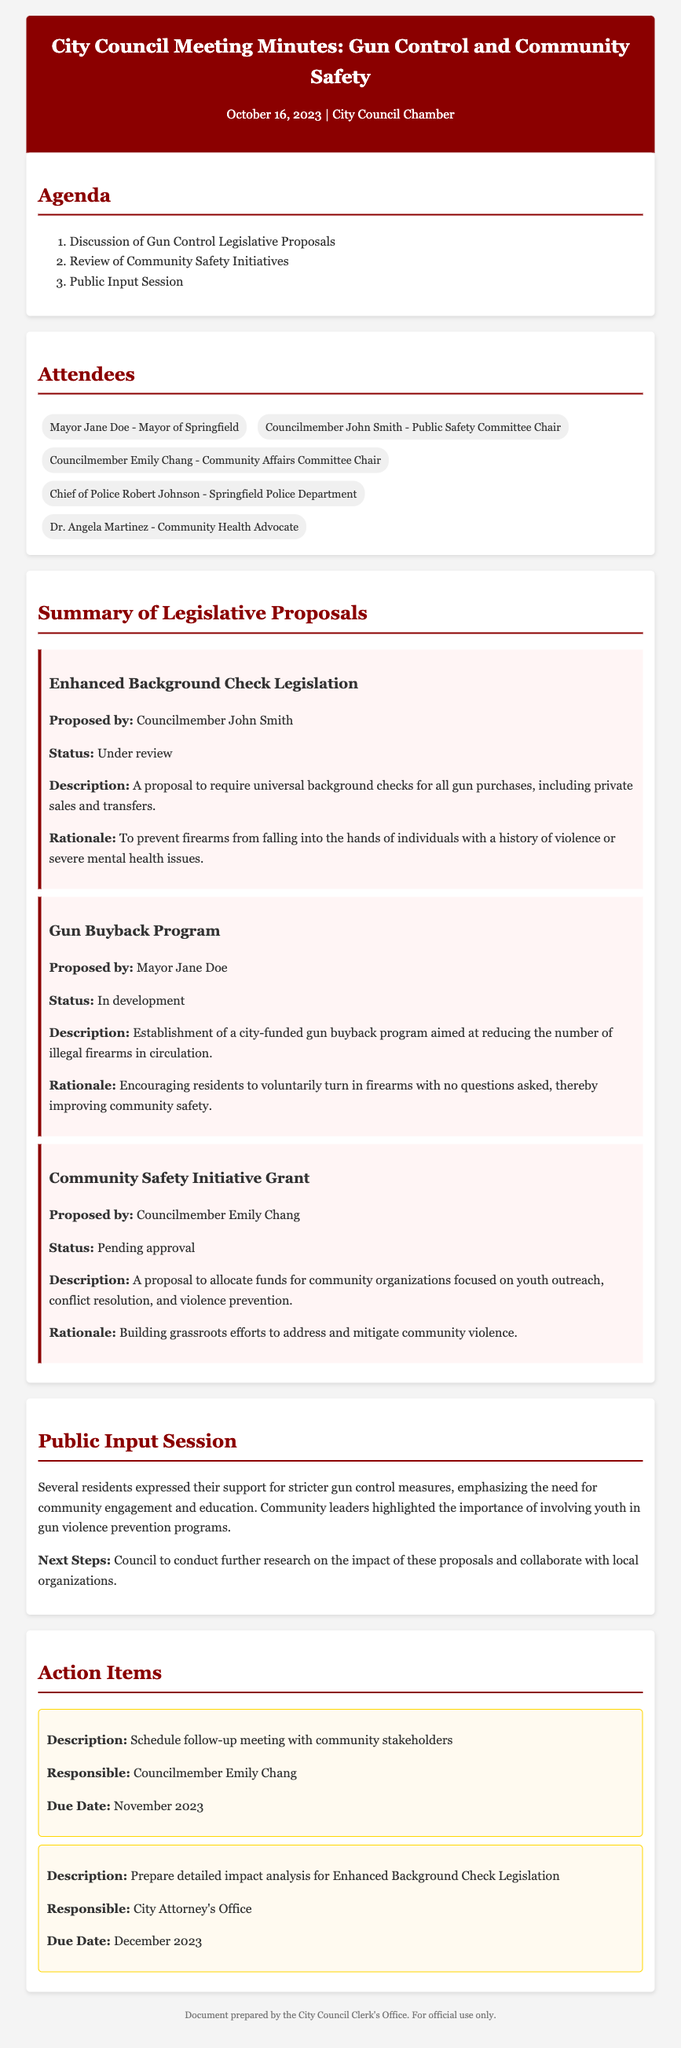What is the date of the meeting? The date of the meeting is specified in the header of the document.
Answer: October 16, 2023 Who proposed the Enhanced Background Check Legislation? The proposal is attributed to a specific council member mentioned in the legislative proposals section.
Answer: Councilmember John Smith What is the status of the Gun Buyback Program? The status of this proposal is clearly stated in the document under the summary of legislative proposals.
Answer: In development What is the rationale behind the Community Safety Initiative Grant? The rationale for this proposal is provided in its description, explaining its purpose and goals.
Answer: Building grassroots efforts to address and mitigate community violence What is the responsible party for the follow-up meeting with community stakeholders? The document specifies the person responsible for this action item in the action items section.
Answer: Councilmember Emily Chang How many attendees were mentioned in the meeting? The number of attendees is listed in the attendees section of the document.
Answer: Five What does the public input session highlight regarding youth involvement? The summary of public input provides insights on community perspectives shared during the meeting.
Answer: Involving youth in gun violence prevention programs What is one action item due in December 2023? The action items section outlines specific tasks assigned with due dates.
Answer: Prepare detailed impact analysis for Enhanced Background Check Legislation 